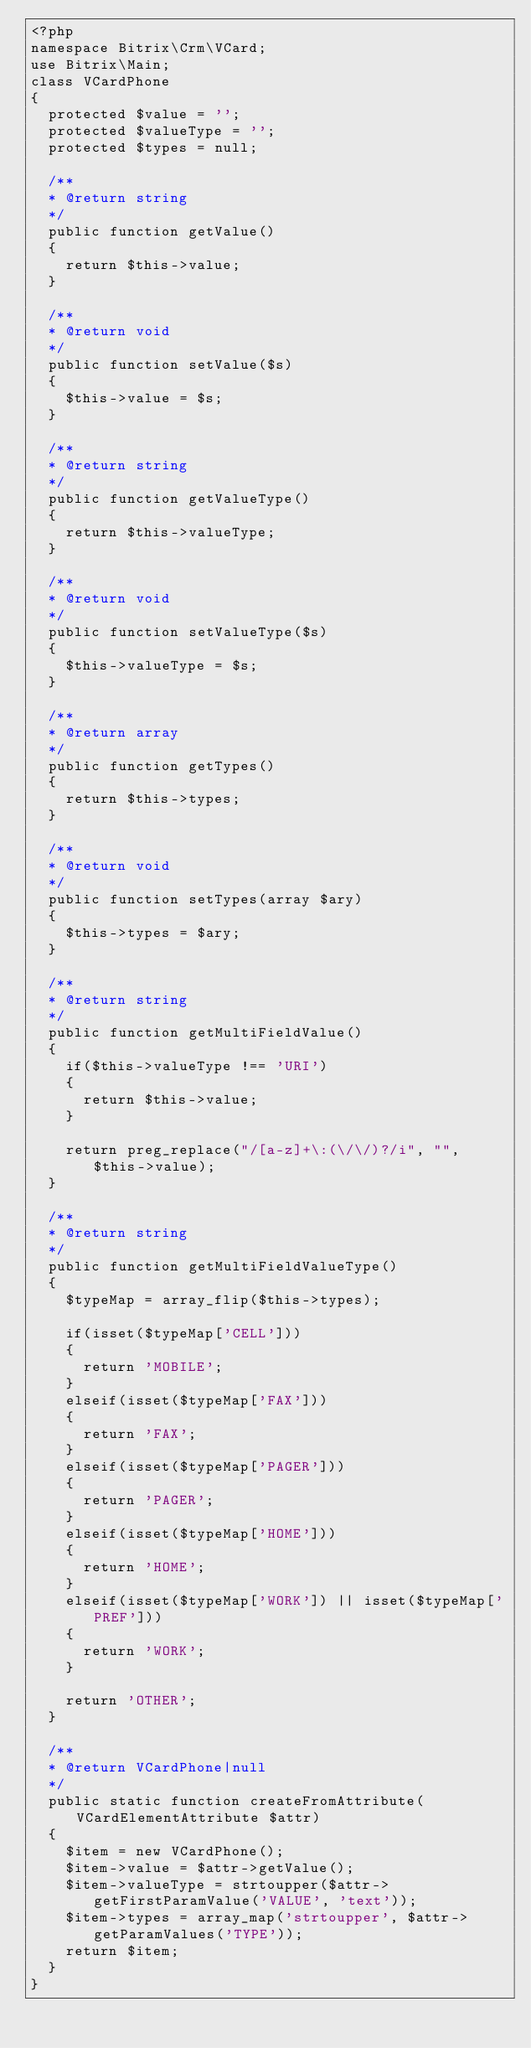Convert code to text. <code><loc_0><loc_0><loc_500><loc_500><_PHP_><?php
namespace Bitrix\Crm\VCard;
use Bitrix\Main;
class VCardPhone
{
	protected $value = '';
	protected $valueType = '';
	protected $types = null;

	/**
	* @return string
	*/
	public function getValue()
	{
		return $this->value;
	}

	/**
	* @return void
	*/
	public function setValue($s)
	{
		$this->value = $s;
	}

	/**
	* @return string
	*/
	public function getValueType()
	{
		return $this->valueType;
	}

	/**
	* @return void
	*/
	public function setValueType($s)
	{
		$this->valueType = $s;
	}

	/**
	* @return array
	*/
	public function getTypes()
	{
		return $this->types;
	}

	/**
	* @return void
	*/
	public function setTypes(array $ary)
	{
		$this->types = $ary;
	}

	/**
	* @return string
	*/
	public function getMultiFieldValue()
	{
		if($this->valueType !== 'URI')
		{
			return $this->value;
		}

		return preg_replace("/[a-z]+\:(\/\/)?/i", "", $this->value);
	}

	/**
	* @return string
	*/
	public function getMultiFieldValueType()
	{
		$typeMap = array_flip($this->types);

		if(isset($typeMap['CELL']))
		{
			return 'MOBILE';
		}
		elseif(isset($typeMap['FAX']))
		{
			return 'FAX';
		}
		elseif(isset($typeMap['PAGER']))
		{
			return 'PAGER';
		}
		elseif(isset($typeMap['HOME']))
		{
			return 'HOME';
		}
		elseif(isset($typeMap['WORK']) || isset($typeMap['PREF']))
		{
			return 'WORK';
		}

		return 'OTHER';
	}

	/**
	* @return VCardPhone|null
	*/
	public static function createFromAttribute(VCardElementAttribute $attr)
	{
		$item = new VCardPhone();
		$item->value = $attr->getValue();
		$item->valueType = strtoupper($attr->getFirstParamValue('VALUE', 'text'));
		$item->types = array_map('strtoupper', $attr->getParamValues('TYPE'));
		return $item;
	}
}</code> 